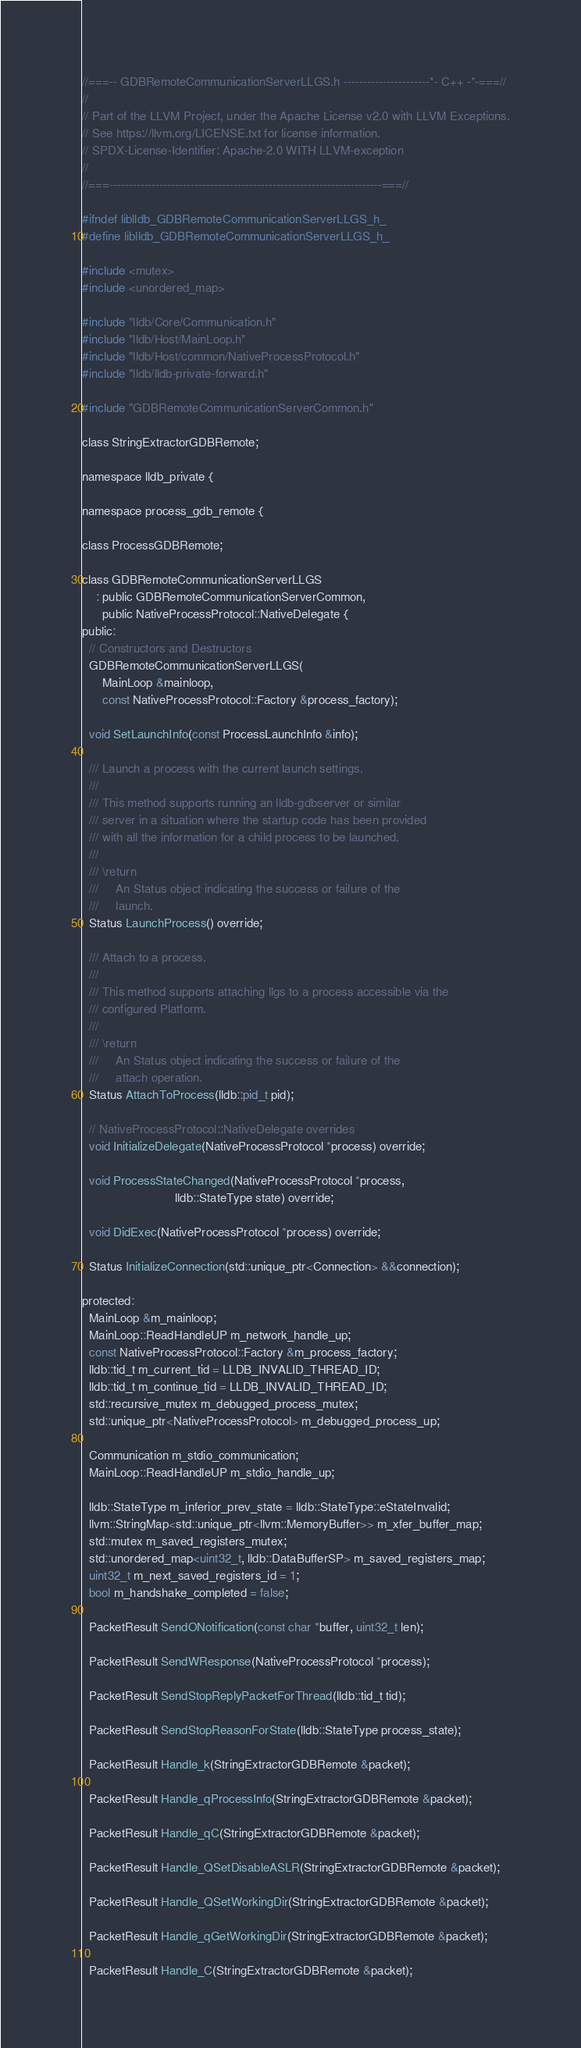<code> <loc_0><loc_0><loc_500><loc_500><_C_>//===-- GDBRemoteCommunicationServerLLGS.h ----------------------*- C++ -*-===//
//
// Part of the LLVM Project, under the Apache License v2.0 with LLVM Exceptions.
// See https://llvm.org/LICENSE.txt for license information.
// SPDX-License-Identifier: Apache-2.0 WITH LLVM-exception
//
//===----------------------------------------------------------------------===//

#ifndef liblldb_GDBRemoteCommunicationServerLLGS_h_
#define liblldb_GDBRemoteCommunicationServerLLGS_h_

#include <mutex>
#include <unordered_map>

#include "lldb/Core/Communication.h"
#include "lldb/Host/MainLoop.h"
#include "lldb/Host/common/NativeProcessProtocol.h"
#include "lldb/lldb-private-forward.h"

#include "GDBRemoteCommunicationServerCommon.h"

class StringExtractorGDBRemote;

namespace lldb_private {

namespace process_gdb_remote {

class ProcessGDBRemote;

class GDBRemoteCommunicationServerLLGS
    : public GDBRemoteCommunicationServerCommon,
      public NativeProcessProtocol::NativeDelegate {
public:
  // Constructors and Destructors
  GDBRemoteCommunicationServerLLGS(
      MainLoop &mainloop,
      const NativeProcessProtocol::Factory &process_factory);

  void SetLaunchInfo(const ProcessLaunchInfo &info);

  /// Launch a process with the current launch settings.
  ///
  /// This method supports running an lldb-gdbserver or similar
  /// server in a situation where the startup code has been provided
  /// with all the information for a child process to be launched.
  ///
  /// \return
  ///     An Status object indicating the success or failure of the
  ///     launch.
  Status LaunchProcess() override;

  /// Attach to a process.
  ///
  /// This method supports attaching llgs to a process accessible via the
  /// configured Platform.
  ///
  /// \return
  ///     An Status object indicating the success or failure of the
  ///     attach operation.
  Status AttachToProcess(lldb::pid_t pid);

  // NativeProcessProtocol::NativeDelegate overrides
  void InitializeDelegate(NativeProcessProtocol *process) override;

  void ProcessStateChanged(NativeProcessProtocol *process,
                           lldb::StateType state) override;

  void DidExec(NativeProcessProtocol *process) override;

  Status InitializeConnection(std::unique_ptr<Connection> &&connection);

protected:
  MainLoop &m_mainloop;
  MainLoop::ReadHandleUP m_network_handle_up;
  const NativeProcessProtocol::Factory &m_process_factory;
  lldb::tid_t m_current_tid = LLDB_INVALID_THREAD_ID;
  lldb::tid_t m_continue_tid = LLDB_INVALID_THREAD_ID;
  std::recursive_mutex m_debugged_process_mutex;
  std::unique_ptr<NativeProcessProtocol> m_debugged_process_up;

  Communication m_stdio_communication;
  MainLoop::ReadHandleUP m_stdio_handle_up;

  lldb::StateType m_inferior_prev_state = lldb::StateType::eStateInvalid;
  llvm::StringMap<std::unique_ptr<llvm::MemoryBuffer>> m_xfer_buffer_map;
  std::mutex m_saved_registers_mutex;
  std::unordered_map<uint32_t, lldb::DataBufferSP> m_saved_registers_map;
  uint32_t m_next_saved_registers_id = 1;
  bool m_handshake_completed = false;

  PacketResult SendONotification(const char *buffer, uint32_t len);

  PacketResult SendWResponse(NativeProcessProtocol *process);

  PacketResult SendStopReplyPacketForThread(lldb::tid_t tid);

  PacketResult SendStopReasonForState(lldb::StateType process_state);

  PacketResult Handle_k(StringExtractorGDBRemote &packet);

  PacketResult Handle_qProcessInfo(StringExtractorGDBRemote &packet);

  PacketResult Handle_qC(StringExtractorGDBRemote &packet);

  PacketResult Handle_QSetDisableASLR(StringExtractorGDBRemote &packet);

  PacketResult Handle_QSetWorkingDir(StringExtractorGDBRemote &packet);

  PacketResult Handle_qGetWorkingDir(StringExtractorGDBRemote &packet);

  PacketResult Handle_C(StringExtractorGDBRemote &packet);
</code> 